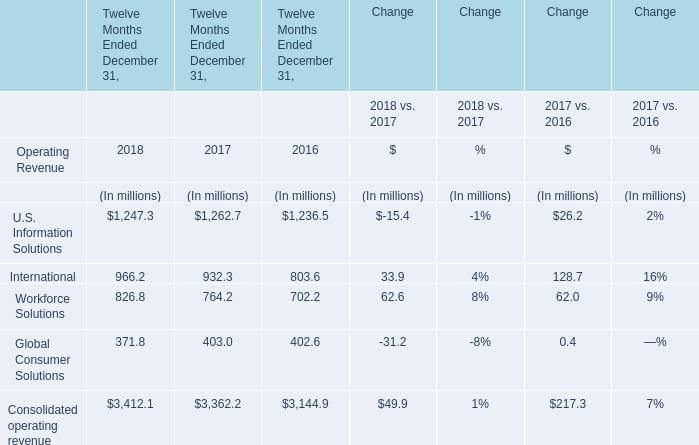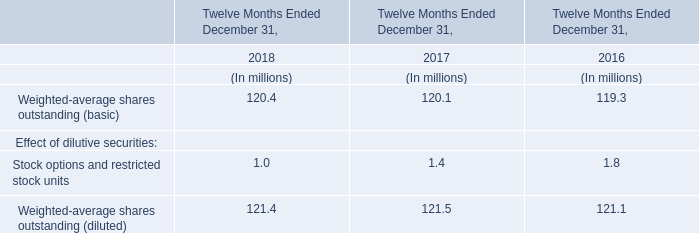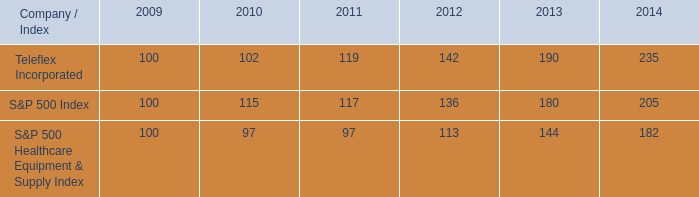What's the total amount of the International for Twelve Months Ended December 31, in the years where Weighted-average shares outstanding (basic) is greater than 0? (in million) 
Computations: ((966.2 + 932.3) + 803.6)
Answer: 2702.1. 